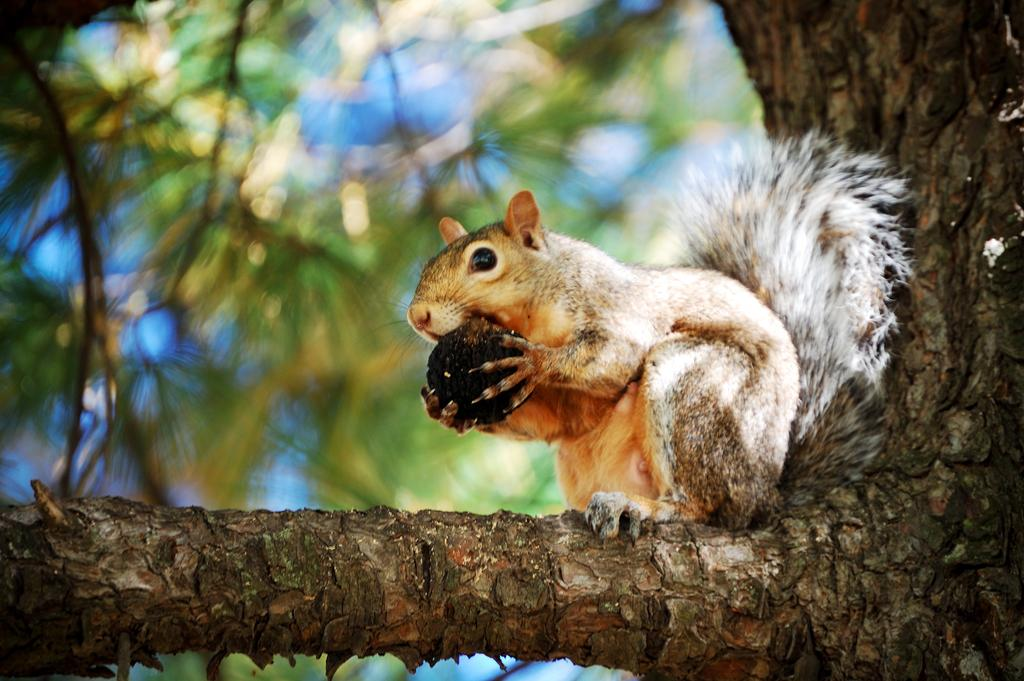What animal is present in the image? There is a squirrel in the image. What is the squirrel holding in its hands? The squirrel is holding a nut. Where is the squirrel sitting in the image? The squirrel is sitting on a branch of a tree. Can you describe the background of the image? The background of the image is blurred. Is there a bridge visible in the image? No, there is no bridge present in the image. What type of alley can be seen in the background of the image? There is no alley present in the image; the background is blurred. 